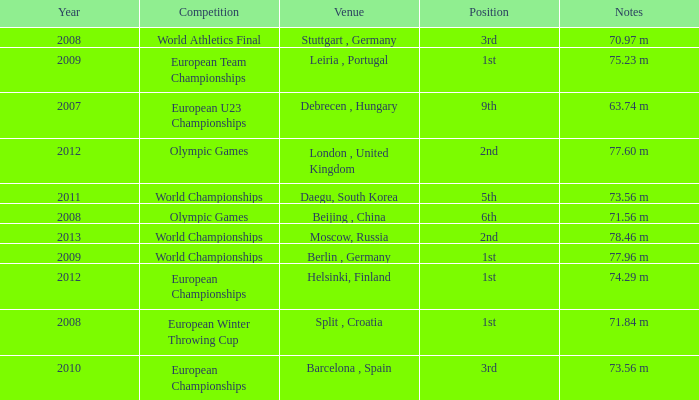What were the notes in 2011? 73.56 m. 